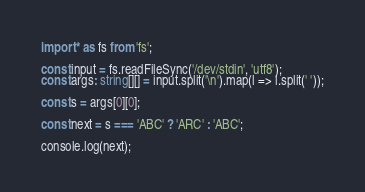Convert code to text. <code><loc_0><loc_0><loc_500><loc_500><_TypeScript_>import * as fs from 'fs';

const input = fs.readFileSync('/dev/stdin', 'utf8');
const args: string[][] = input.split('\n').map(l => l.split(' '));

const s = args[0][0];

const next = s === 'ABC' ? 'ARC' : 'ABC';

console.log(next);</code> 